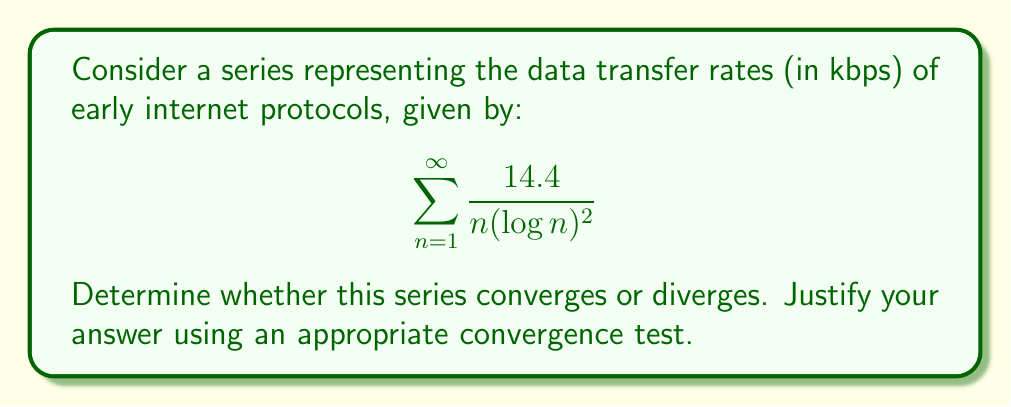Show me your answer to this math problem. To determine the convergence of this series, we can use the integral test. This test is appropriate because the function $f(x) = \frac{14.4}{x(\log x)^2}$ is positive and decreasing for $x \geq 2$.

1) First, we need to check if the integral $\int_2^{\infty} \frac{14.4}{x(\log x)^2} dx$ converges.

2) Let's evaluate this integral:

   $$ \int \frac{14.4}{x(\log x)^2} dx = -\frac{14.4}{\log x} + C $$

3) Now, let's evaluate the definite integral:

   $$ \lim_{b \to \infty} \left[-\frac{14.4}{\log x}\right]_2^b = \lim_{b \to \infty} \left(-\frac{14.4}{\log b} + \frac{14.4}{\log 2}\right) $$

4) As $b \to \infty$, $\log b \to \infty$, so $-\frac{14.4}{\log b} \to 0$. Therefore:

   $$ \lim_{b \to \infty} \left(-\frac{14.4}{\log b} + \frac{14.4}{\log 2}\right) = 0 + \frac{14.4}{\log 2} $$

5) This limit exists and is finite, which means the integral converges.

6) By the integral test, if the integral converges, then the series converges as well.

This result is interesting in the context of early internet protocols. The convergence of this series suggests that the cumulative data transfer rate across all iterations (which could represent different versions or implementations of the protocol) remains bounded, despite the theoretical infinite sum. This aligns with the practical limitations of early internet technologies, where data transfer rates were constrained by hardware and network infrastructure.
Answer: The series $\sum_{n=1}^{\infty} \frac{14.4}{n(\log n)^2}$ converges. 